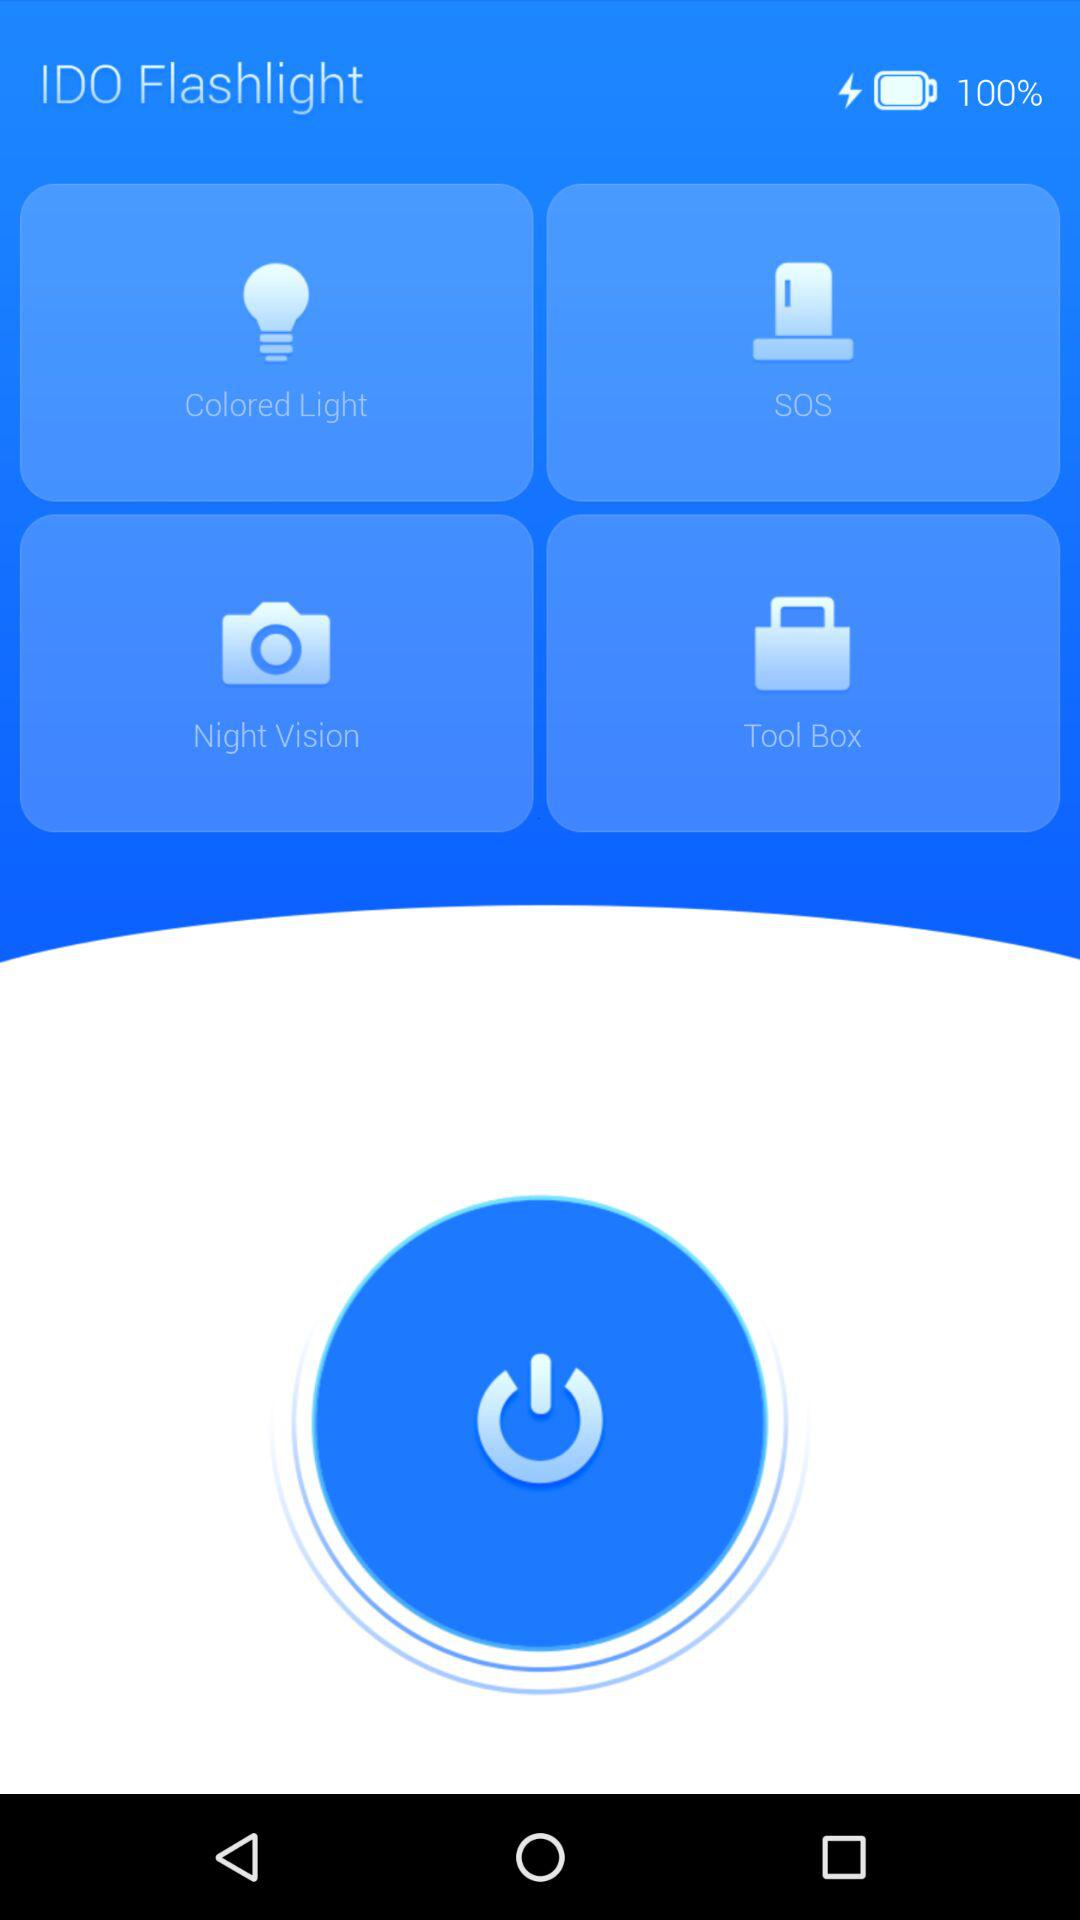What is the percentage of the battery? The percentage is 100%. 